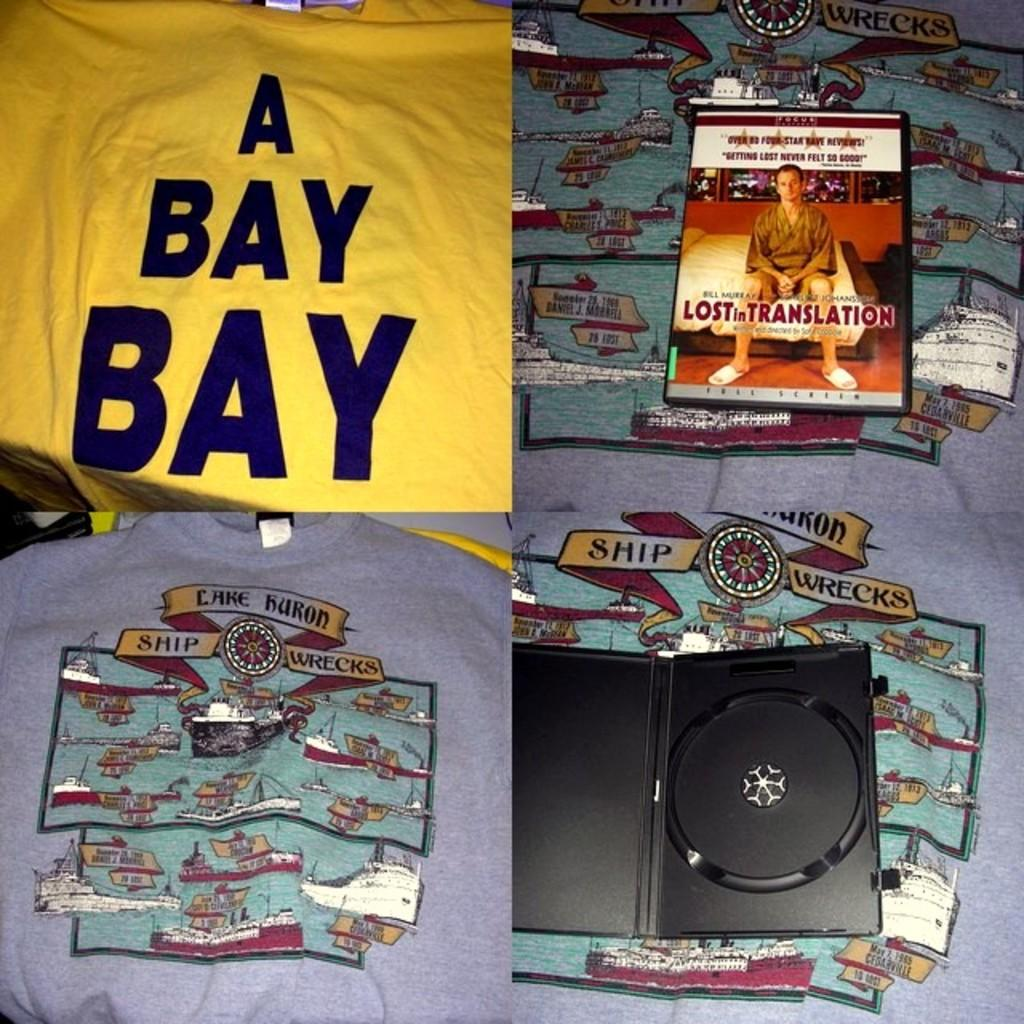Provide a one-sentence caption for the provided image. One one side of the screen you will see an open DVD cover and a DVD of the movie "Lost in Translation. 